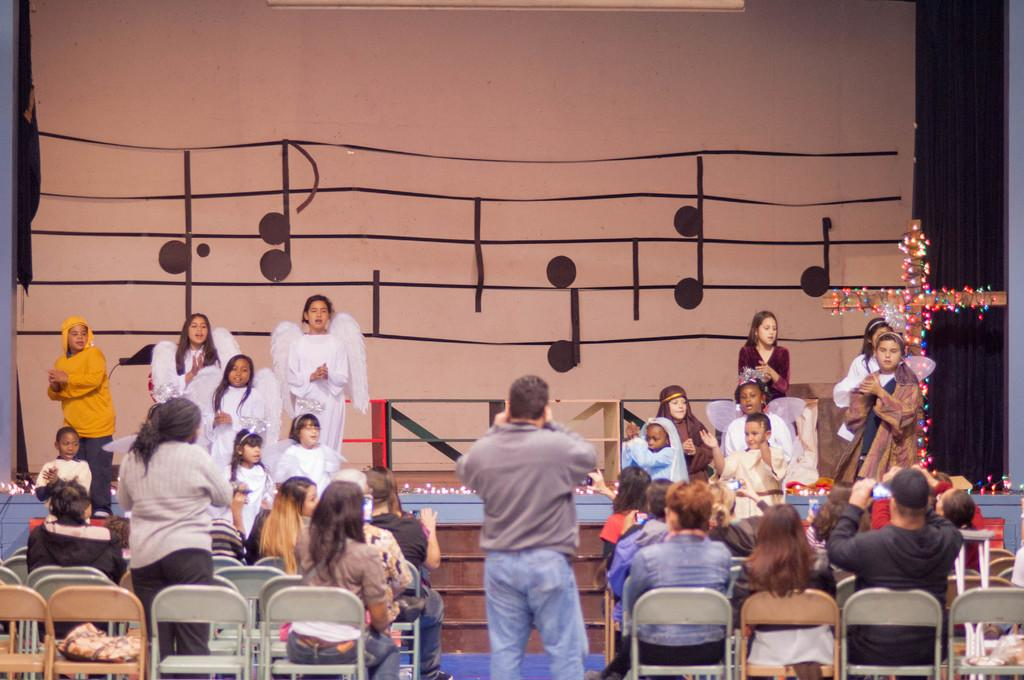What are the kids doing in the image? The kids are standing on a dais in the image. What are the people in the image doing? The people are sitting in chairs in the image. Who is capturing the moment in the image? There is a person taking a picture in the image. What type of egg is being used to power the current in the image? There is no egg or current present in the image; it features kids standing on a dais and people sitting in chairs. 